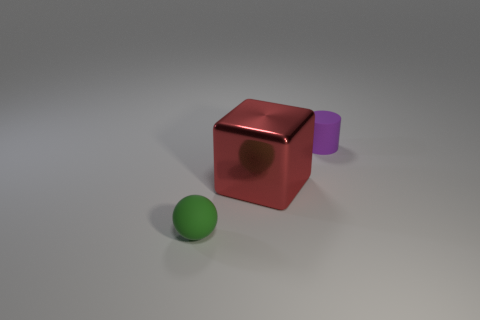Add 2 large red cylinders. How many objects exist? 5 Subtract all balls. How many objects are left? 2 Subtract all big green things. Subtract all tiny things. How many objects are left? 1 Add 1 matte spheres. How many matte spheres are left? 2 Add 1 tiny brown matte blocks. How many tiny brown matte blocks exist? 1 Subtract 0 gray blocks. How many objects are left? 3 